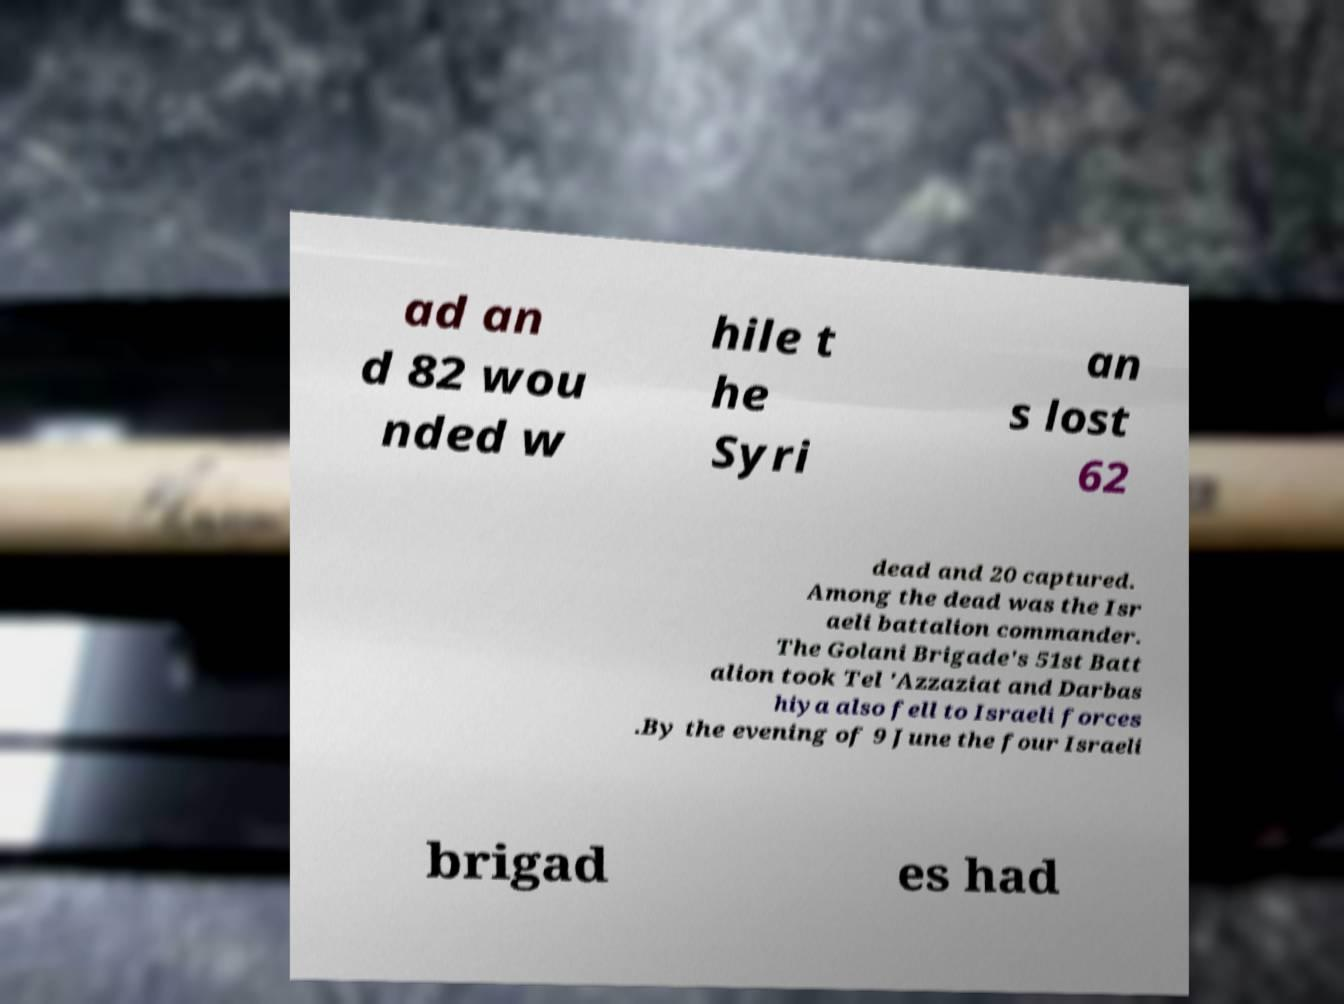Please identify and transcribe the text found in this image. ad an d 82 wou nded w hile t he Syri an s lost 62 dead and 20 captured. Among the dead was the Isr aeli battalion commander. The Golani Brigade's 51st Batt alion took Tel 'Azzaziat and Darbas hiya also fell to Israeli forces .By the evening of 9 June the four Israeli brigad es had 